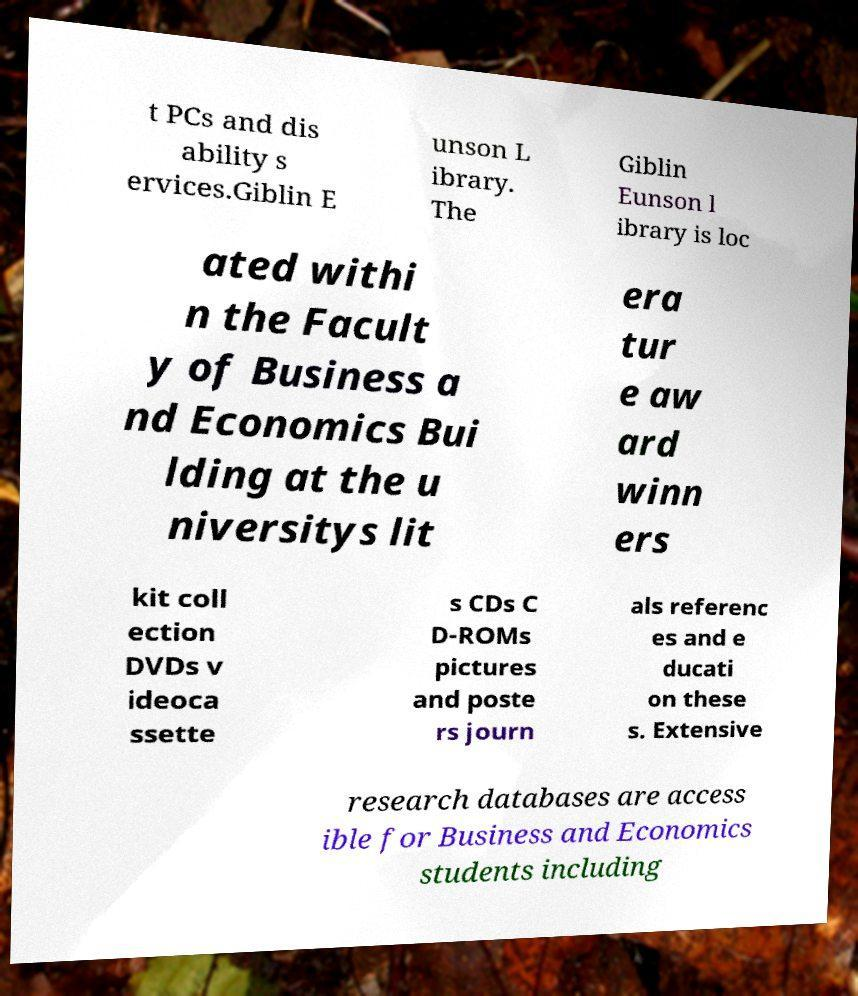Could you extract and type out the text from this image? t PCs and dis ability s ervices.Giblin E unson L ibrary. The Giblin Eunson l ibrary is loc ated withi n the Facult y of Business a nd Economics Bui lding at the u niversitys lit era tur e aw ard winn ers kit coll ection DVDs v ideoca ssette s CDs C D-ROMs pictures and poste rs journ als referenc es and e ducati on these s. Extensive research databases are access ible for Business and Economics students including 